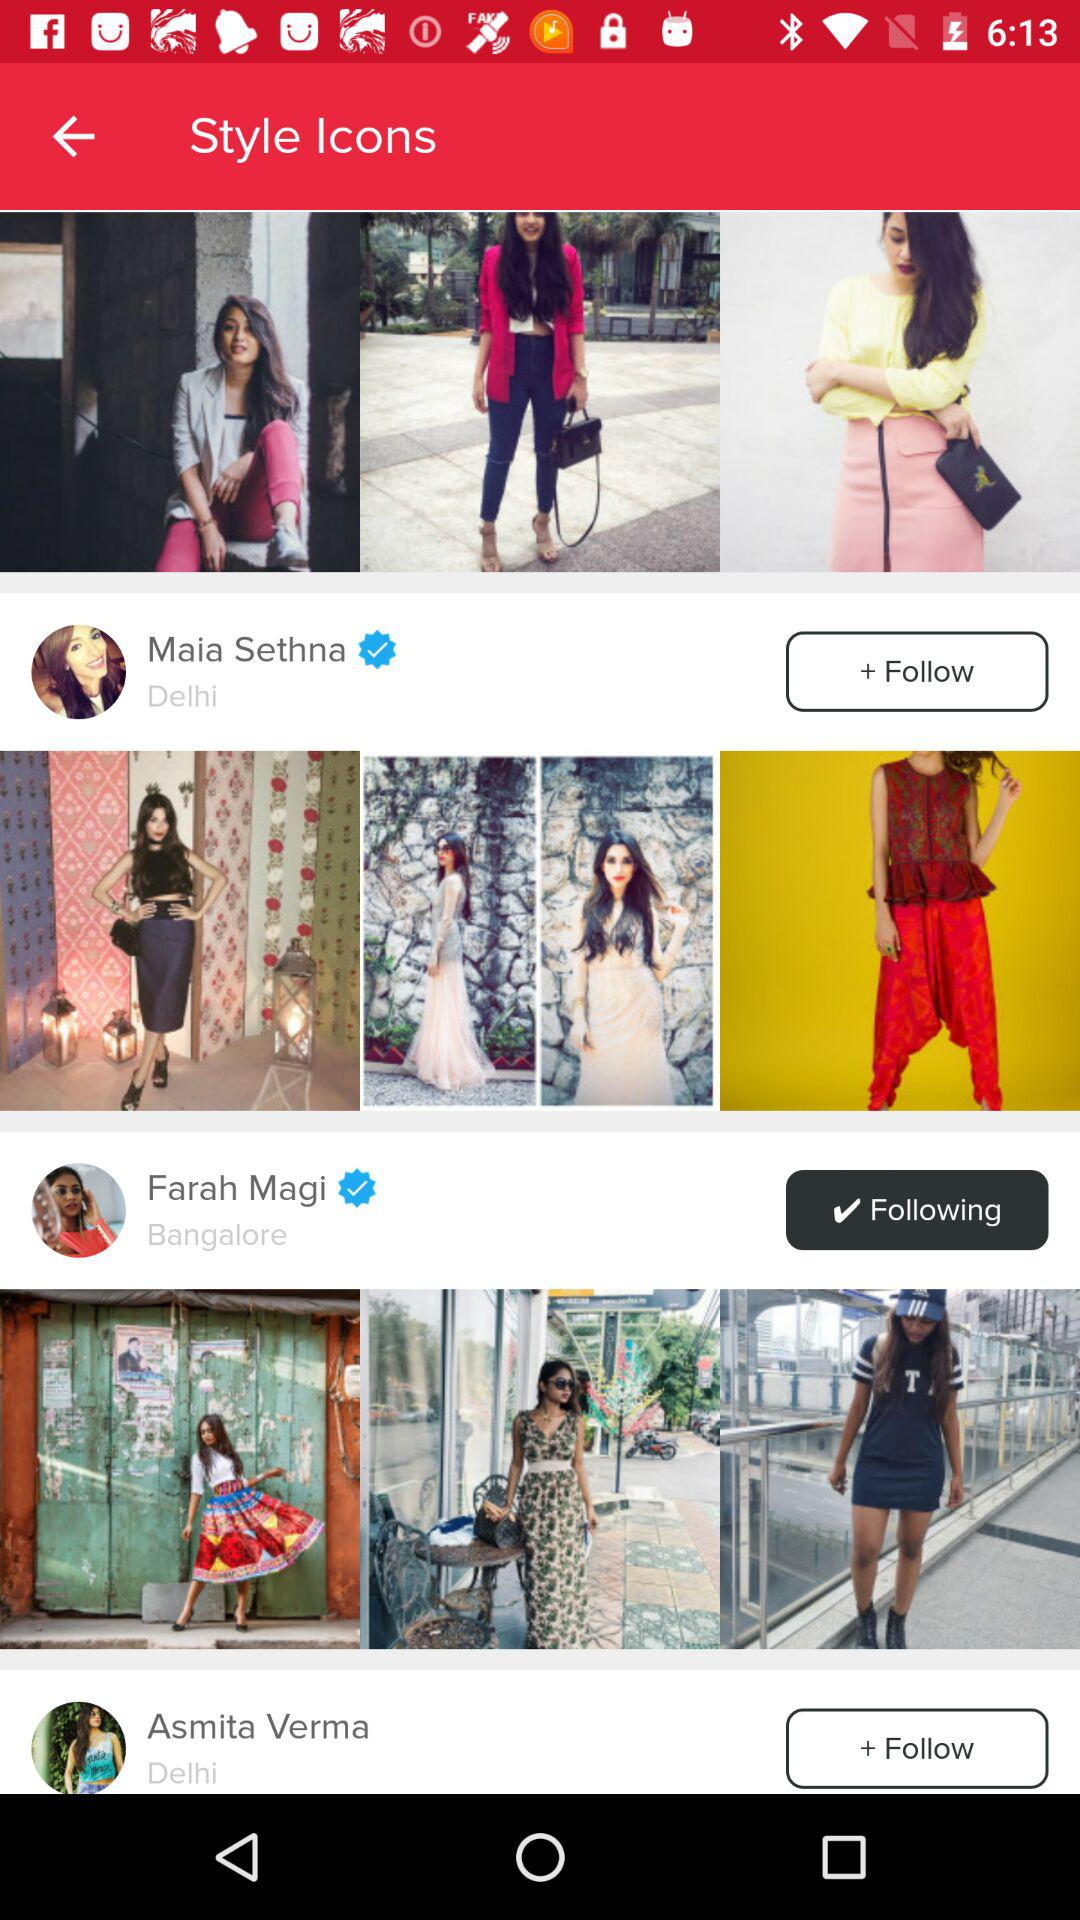What is the location of Farah Magi? The location of Farah Magi is Bangalore. 